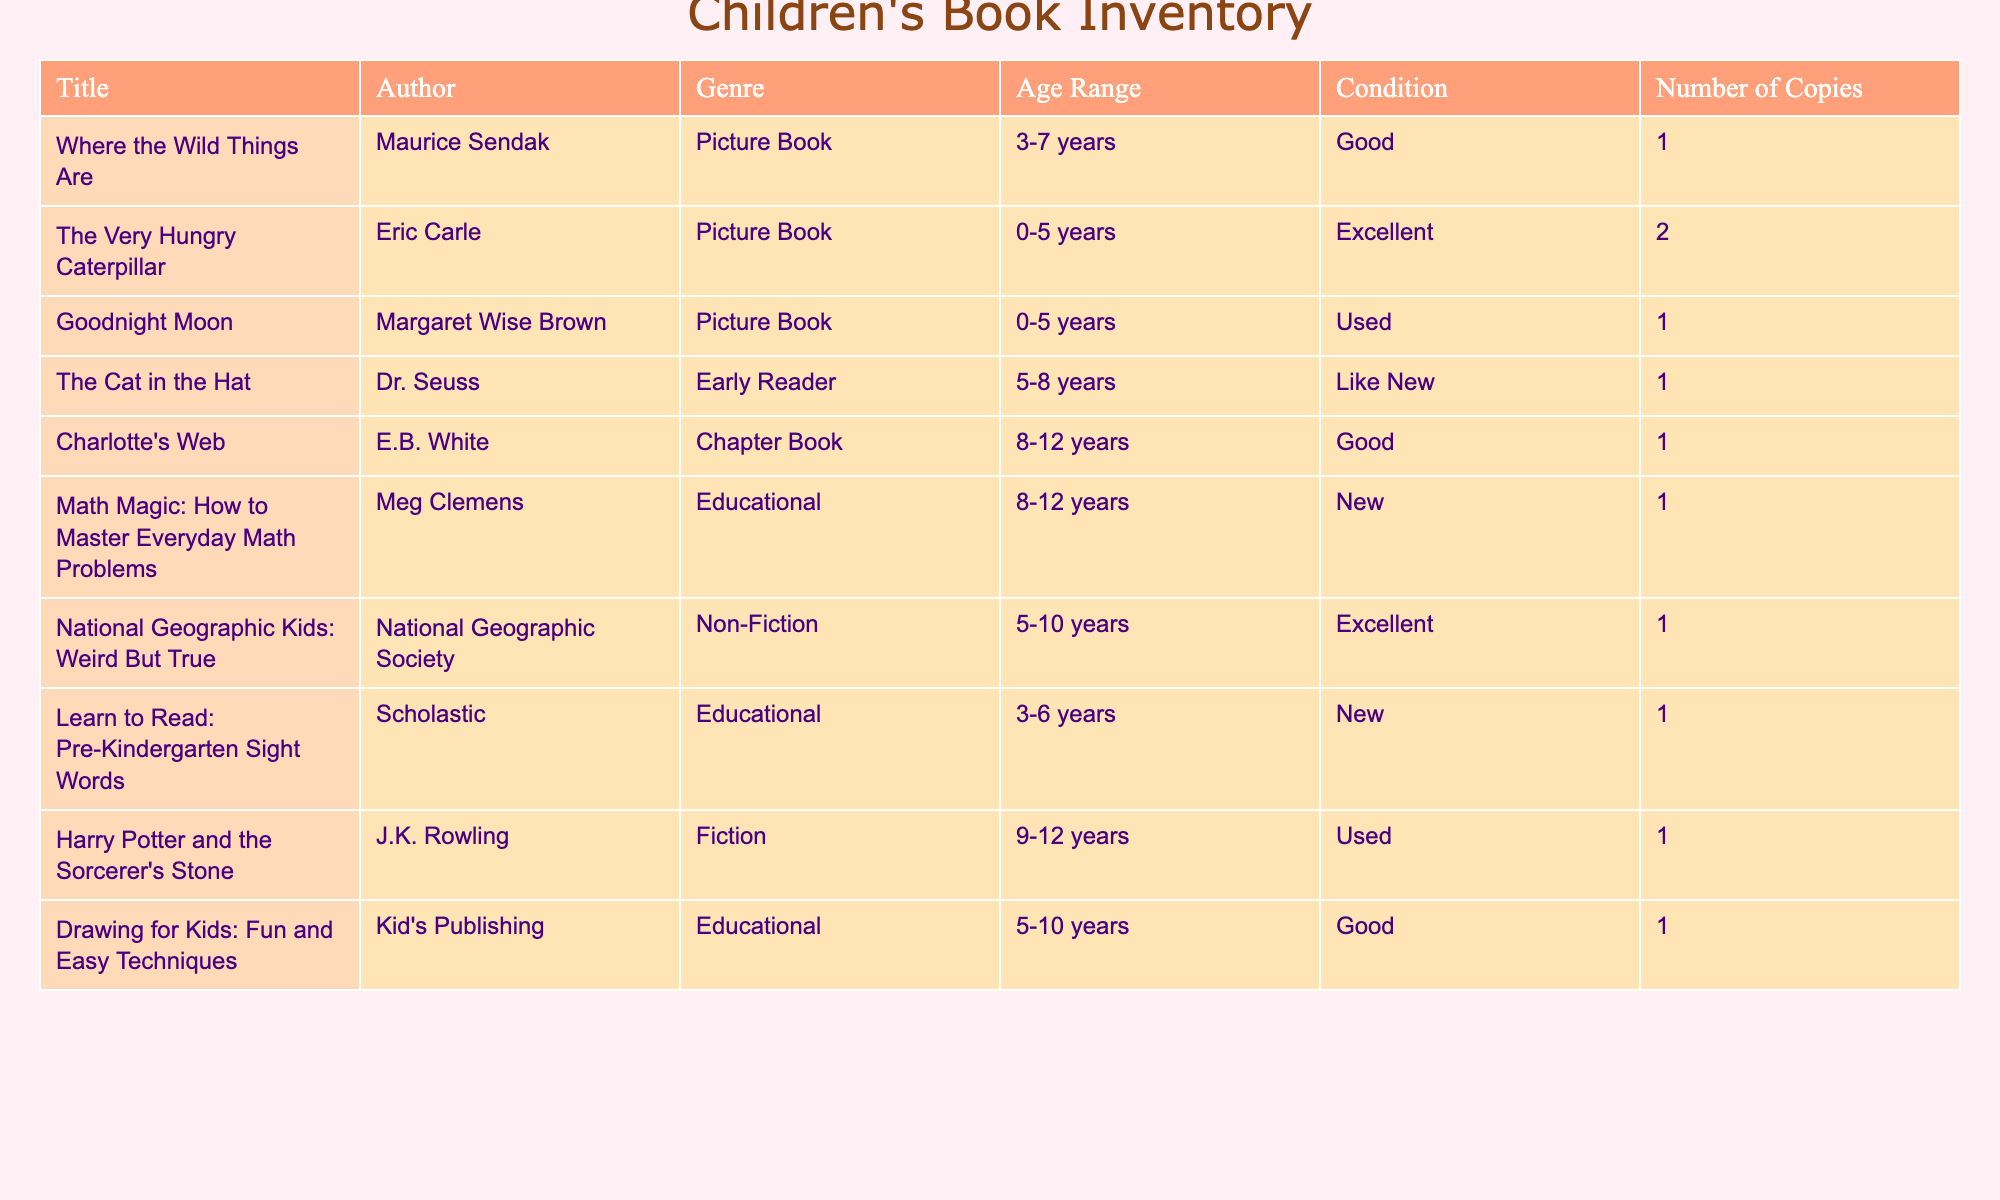What is the title of the book authored by Eric Carle? The author's name "Eric Carle" is present in the second row of the table, and the title corresponding to that author is "The Very Hungry Caterpillar".
Answer: The Very Hungry Caterpillar How many copies of "Charlotte's Web" do we have? In the table, under the title "Charlotte's Web", the column for the number of copies shows "1".
Answer: 1 Is "Harry Potter and the Sorcerer's Stone" classified as a Non-Fiction book? The table lists "Harry Potter and the Sorcerer's Stone" under the genre "Fiction", which indicates that it is not categorized as Non-Fiction.
Answer: No What is the age range for "Learn to Read: Pre-Kindergarten Sight Words"? The table shows the age range for "Learn to Read: Pre-Kindergarten Sight Words" as "3-6 years".
Answer: 3-6 years How many Picture Books do we have in total? The total number of Picture Books can be retrieved by counting the number of entries in the genre "Picture Book". The count is 3 (Where the Wild Things Are, The Very Hungry Caterpillar, Goodnight Moon).
Answer: 3 Which book has the most copies? By inspecting the number of copies for all the books, "The Very Hungry Caterpillar" has 2 copies, while all other titles have 1 copy.
Answer: The Very Hungry Caterpillar Are all the educational books in new condition? The educational books listed are "Math Magic: How to Master Everyday Math Problems", "Learn to Read: Pre-Kindergarten Sight Words", and "Drawing for Kids: Fun and Easy Techniques". Among these, only "Math Magic" and "Learn to Read" are in new condition, so not all are new.
Answer: No What is the average number of copies for all books listed in the inventory? The total number of copies is 1 (for Where the Wild Things Are) + 2 (for The Very Hungry Caterpillar) + 1 (for Goodnight Moon) + 1 + 1 + 1 + 1 + 1 + 1 = 10. There are 10 books in total, so the average is 10/10 = 1.
Answer: 1 Which author has written more than one book? By looking through the table, none of the authors listed have more than one book in the inventory. As a result, the answer is no.
Answer: No 